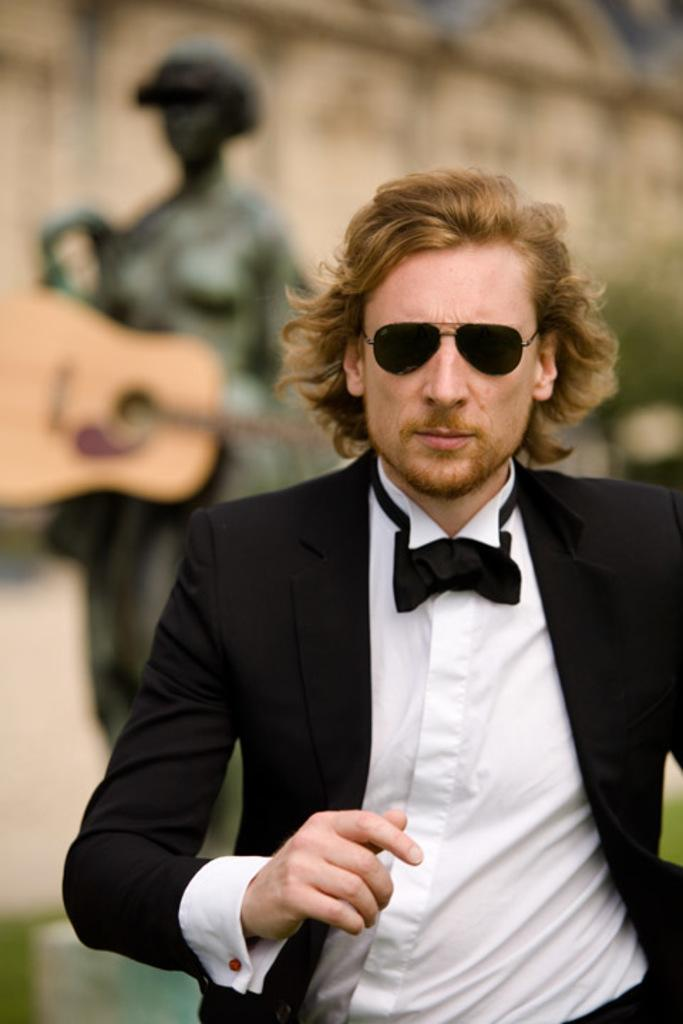Who is present in the image? There is a man in the image. What is the man wearing on his face? The man is wearing goggles. What can be seen in the background of the image? There is a statue and a guitar in the background of the image. How would you describe the appearance of the background elements? The background elements appear blurry. What language is the fish speaking in the image? There is no fish present in the image, so it is not possible to determine what language it might be speaking. 